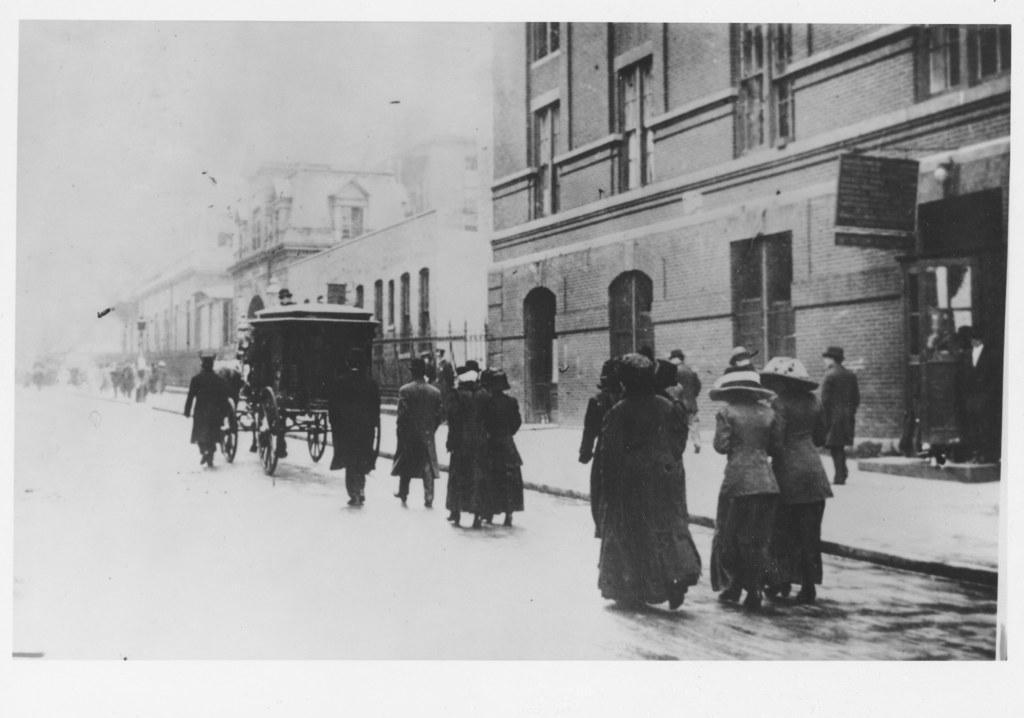Can you describe this image briefly? As we can see in the image there is cart, group of people, buildings and windows. At the top there is sky. 